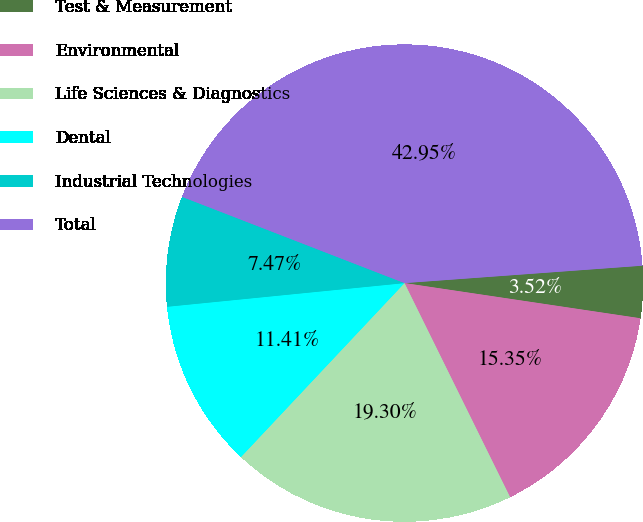Convert chart. <chart><loc_0><loc_0><loc_500><loc_500><pie_chart><fcel>Test & Measurement<fcel>Environmental<fcel>Life Sciences & Diagnostics<fcel>Dental<fcel>Industrial Technologies<fcel>Total<nl><fcel>3.52%<fcel>15.35%<fcel>19.3%<fcel>11.41%<fcel>7.47%<fcel>42.95%<nl></chart> 